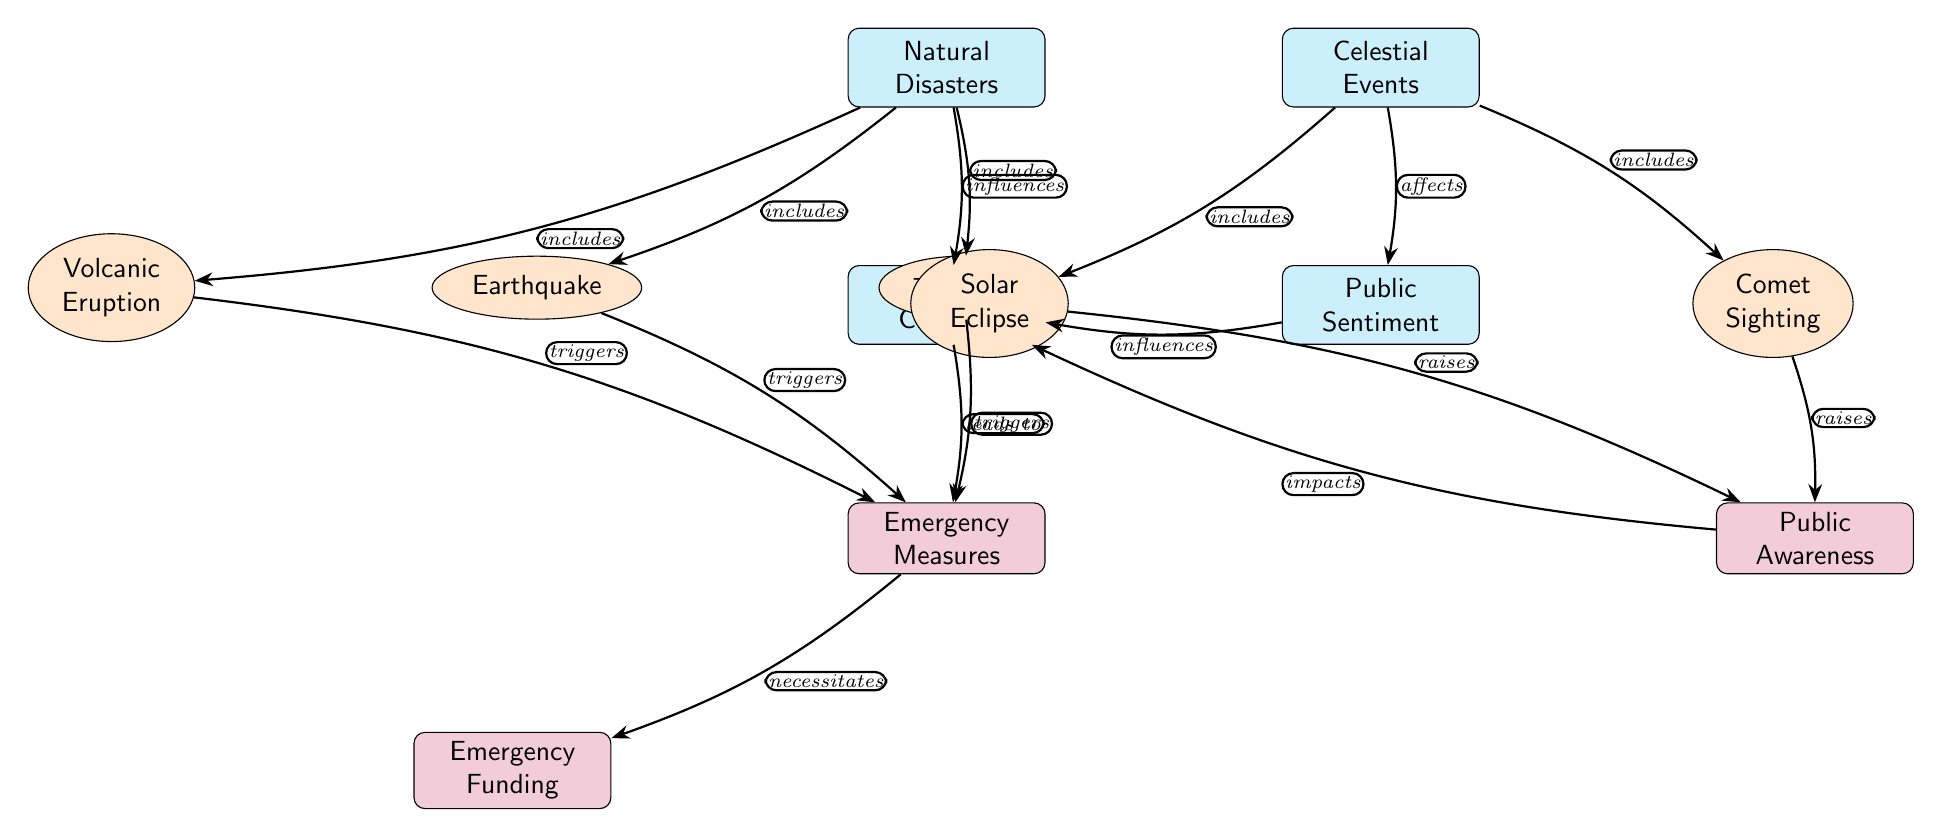What are the three types of natural disasters represented in the diagram? The diagram shows three types of natural disasters: Earthquake, Volcanic Eruption, and Tsunami, which are all subnodes under the main node "Natural Disasters."
Answer: Earthquake, Volcanic Eruption, Tsunami How many edges connect the "Celestial Events" node to its sub-nodes? The "Celestial Events" node is connected to two subnodes: Solar Eclipse and Comet Sighting, which makes for a total of two edges connecting it to its sub-nodes.
Answer: 2 What do natural disasters influence in the diagram? The diagram illustrates that natural disasters influence the "Policy Changes" node, showing that they have an impact on how political decisions are made in response to these events.
Answer: Policy Changes Which event raises public awareness according to the diagram? Both Solar Eclipse and Comet Sighting events are depicted as raising public awareness, indicating they contribute to changes in public sentiment regarding political actions.
Answer: Solar Eclipse, Comet Sighting What are the consequences of the "Policy Changes" node according to the diagram? The "Policy Changes" node leads to the implementation of "Emergency Measures," which suggests that decisions made in response to disasters and events result in specific actions taken by the government.
Answer: Emergency Measures Which type of node is "Emergency Funding"? "Emergency Funding" is a measure node in the diagram, indicating it is a distinct action or concept tied to the emergency measures taken after natural disasters.
Answer: Measure How do public sentiment and celestial events interact in the diagram? The diagram indicates that public sentiment is affected by celestial events, and in turn, this public sentiment influences policy changes, reflecting a reciprocal relationship between these elements.
Answer: Affects, Influences What triggers the implementation of emergency measures based on the diagram? Earthquake, Volcanic Eruption, and Tsunami are shown to trigger the implementation of emergency measures, indicating that these specific disasters necessitate responsive actions from policymakers.
Answer: Earthquake, Volcanic Eruption, Tsunami 